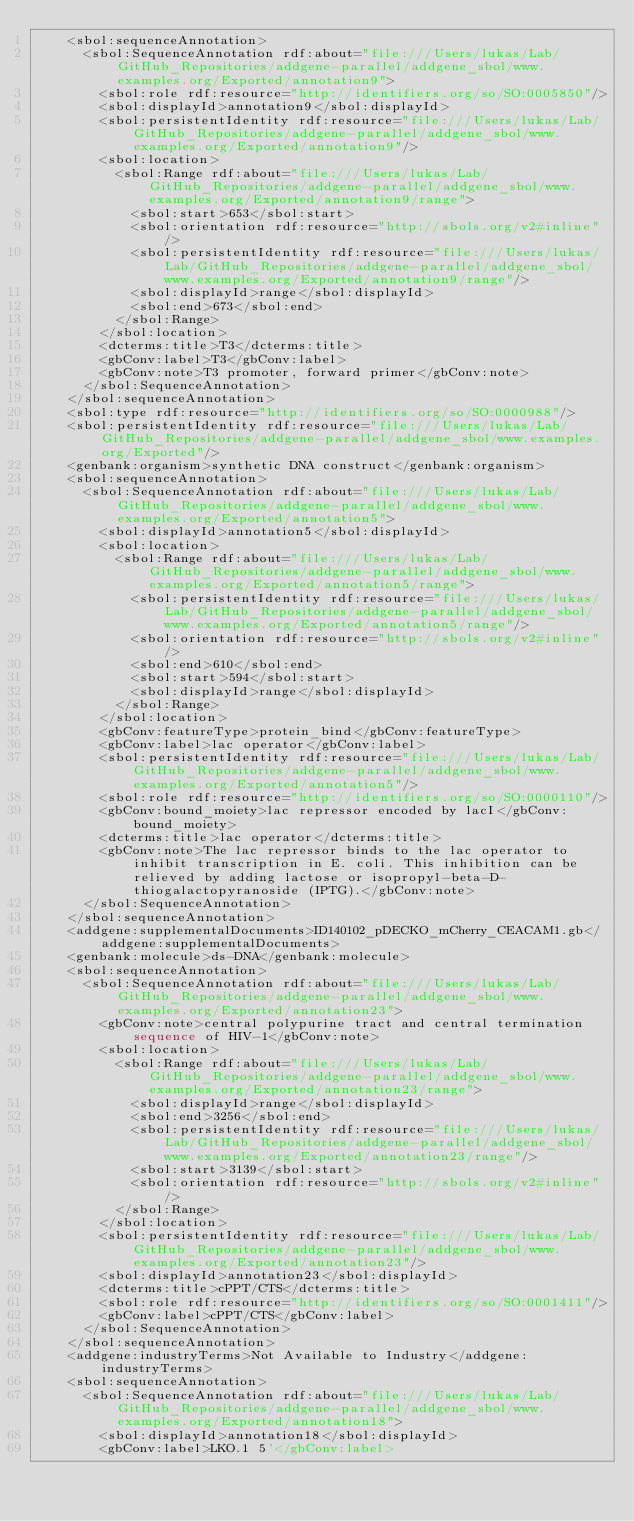<code> <loc_0><loc_0><loc_500><loc_500><_XML_>    <sbol:sequenceAnnotation>
      <sbol:SequenceAnnotation rdf:about="file:///Users/lukas/Lab/GitHub_Repositories/addgene-parallel/addgene_sbol/www.examples.org/Exported/annotation9">
        <sbol:role rdf:resource="http://identifiers.org/so/SO:0005850"/>
        <sbol:displayId>annotation9</sbol:displayId>
        <sbol:persistentIdentity rdf:resource="file:///Users/lukas/Lab/GitHub_Repositories/addgene-parallel/addgene_sbol/www.examples.org/Exported/annotation9"/>
        <sbol:location>
          <sbol:Range rdf:about="file:///Users/lukas/Lab/GitHub_Repositories/addgene-parallel/addgene_sbol/www.examples.org/Exported/annotation9/range">
            <sbol:start>653</sbol:start>
            <sbol:orientation rdf:resource="http://sbols.org/v2#inline"/>
            <sbol:persistentIdentity rdf:resource="file:///Users/lukas/Lab/GitHub_Repositories/addgene-parallel/addgene_sbol/www.examples.org/Exported/annotation9/range"/>
            <sbol:displayId>range</sbol:displayId>
            <sbol:end>673</sbol:end>
          </sbol:Range>
        </sbol:location>
        <dcterms:title>T3</dcterms:title>
        <gbConv:label>T3</gbConv:label>
        <gbConv:note>T3 promoter, forward primer</gbConv:note>
      </sbol:SequenceAnnotation>
    </sbol:sequenceAnnotation>
    <sbol:type rdf:resource="http://identifiers.org/so/SO:0000988"/>
    <sbol:persistentIdentity rdf:resource="file:///Users/lukas/Lab/GitHub_Repositories/addgene-parallel/addgene_sbol/www.examples.org/Exported"/>
    <genbank:organism>synthetic DNA construct</genbank:organism>
    <sbol:sequenceAnnotation>
      <sbol:SequenceAnnotation rdf:about="file:///Users/lukas/Lab/GitHub_Repositories/addgene-parallel/addgene_sbol/www.examples.org/Exported/annotation5">
        <sbol:displayId>annotation5</sbol:displayId>
        <sbol:location>
          <sbol:Range rdf:about="file:///Users/lukas/Lab/GitHub_Repositories/addgene-parallel/addgene_sbol/www.examples.org/Exported/annotation5/range">
            <sbol:persistentIdentity rdf:resource="file:///Users/lukas/Lab/GitHub_Repositories/addgene-parallel/addgene_sbol/www.examples.org/Exported/annotation5/range"/>
            <sbol:orientation rdf:resource="http://sbols.org/v2#inline"/>
            <sbol:end>610</sbol:end>
            <sbol:start>594</sbol:start>
            <sbol:displayId>range</sbol:displayId>
          </sbol:Range>
        </sbol:location>
        <gbConv:featureType>protein_bind</gbConv:featureType>
        <gbConv:label>lac operator</gbConv:label>
        <sbol:persistentIdentity rdf:resource="file:///Users/lukas/Lab/GitHub_Repositories/addgene-parallel/addgene_sbol/www.examples.org/Exported/annotation5"/>
        <sbol:role rdf:resource="http://identifiers.org/so/SO:0000110"/>
        <gbConv:bound_moiety>lac repressor encoded by lacI</gbConv:bound_moiety>
        <dcterms:title>lac operator</dcterms:title>
        <gbConv:note>The lac repressor binds to the lac operator to inhibit transcription in E. coli. This inhibition can be relieved by adding lactose or isopropyl-beta-D-thiogalactopyranoside (IPTG).</gbConv:note>
      </sbol:SequenceAnnotation>
    </sbol:sequenceAnnotation>
    <addgene:supplementalDocuments>ID140102_pDECKO_mCherry_CEACAM1.gb</addgene:supplementalDocuments>
    <genbank:molecule>ds-DNA</genbank:molecule>
    <sbol:sequenceAnnotation>
      <sbol:SequenceAnnotation rdf:about="file:///Users/lukas/Lab/GitHub_Repositories/addgene-parallel/addgene_sbol/www.examples.org/Exported/annotation23">
        <gbConv:note>central polypurine tract and central termination sequence of HIV-1</gbConv:note>
        <sbol:location>
          <sbol:Range rdf:about="file:///Users/lukas/Lab/GitHub_Repositories/addgene-parallel/addgene_sbol/www.examples.org/Exported/annotation23/range">
            <sbol:displayId>range</sbol:displayId>
            <sbol:end>3256</sbol:end>
            <sbol:persistentIdentity rdf:resource="file:///Users/lukas/Lab/GitHub_Repositories/addgene-parallel/addgene_sbol/www.examples.org/Exported/annotation23/range"/>
            <sbol:start>3139</sbol:start>
            <sbol:orientation rdf:resource="http://sbols.org/v2#inline"/>
          </sbol:Range>
        </sbol:location>
        <sbol:persistentIdentity rdf:resource="file:///Users/lukas/Lab/GitHub_Repositories/addgene-parallel/addgene_sbol/www.examples.org/Exported/annotation23"/>
        <sbol:displayId>annotation23</sbol:displayId>
        <dcterms:title>cPPT/CTS</dcterms:title>
        <sbol:role rdf:resource="http://identifiers.org/so/SO:0001411"/>
        <gbConv:label>cPPT/CTS</gbConv:label>
      </sbol:SequenceAnnotation>
    </sbol:sequenceAnnotation>
    <addgene:industryTerms>Not Available to Industry</addgene:industryTerms>
    <sbol:sequenceAnnotation>
      <sbol:SequenceAnnotation rdf:about="file:///Users/lukas/Lab/GitHub_Repositories/addgene-parallel/addgene_sbol/www.examples.org/Exported/annotation18">
        <sbol:displayId>annotation18</sbol:displayId>
        <gbConv:label>LKO.1 5'</gbConv:label></code> 